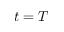<formula> <loc_0><loc_0><loc_500><loc_500>t = T</formula> 